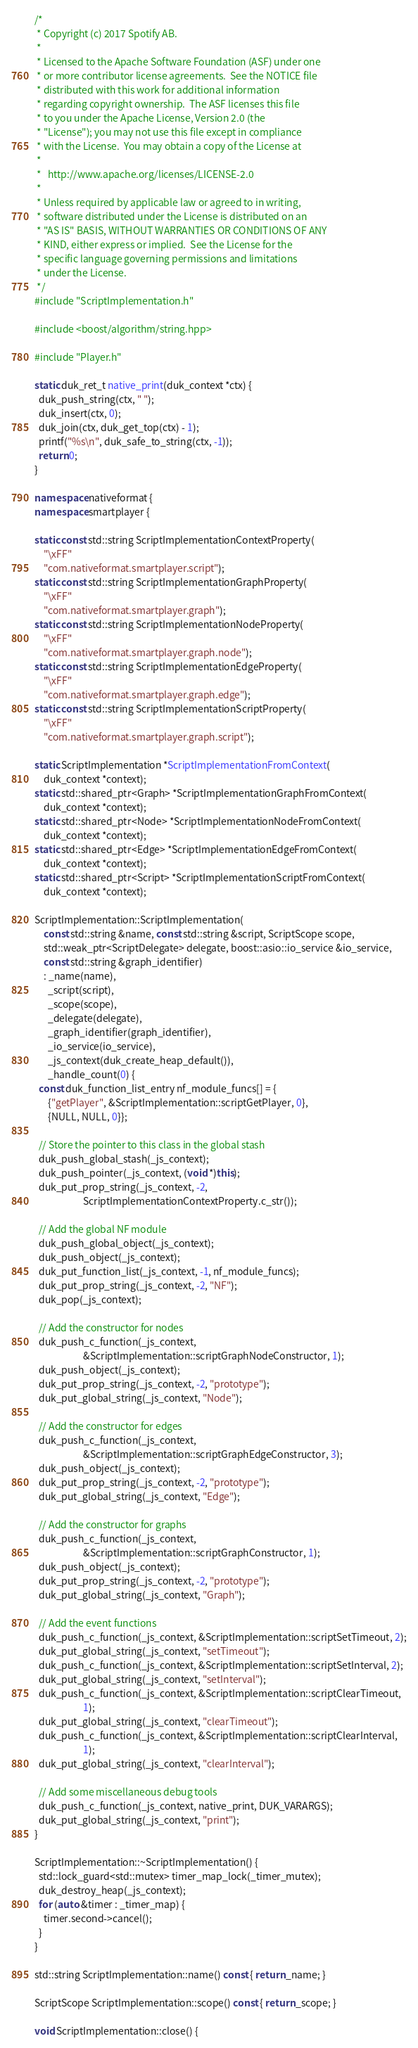Convert code to text. <code><loc_0><loc_0><loc_500><loc_500><_C++_>/*
 * Copyright (c) 2017 Spotify AB.
 *
 * Licensed to the Apache Software Foundation (ASF) under one
 * or more contributor license agreements.  See the NOTICE file
 * distributed with this work for additional information
 * regarding copyright ownership.  The ASF licenses this file
 * to you under the Apache License, Version 2.0 (the
 * "License"); you may not use this file except in compliance
 * with the License.  You may obtain a copy of the License at
 *
 *   http://www.apache.org/licenses/LICENSE-2.0
 *
 * Unless required by applicable law or agreed to in writing,
 * software distributed under the License is distributed on an
 * "AS IS" BASIS, WITHOUT WARRANTIES OR CONDITIONS OF ANY
 * KIND, either express or implied.  See the License for the
 * specific language governing permissions and limitations
 * under the License.
 */
#include "ScriptImplementation.h"

#include <boost/algorithm/string.hpp>

#include "Player.h"

static duk_ret_t native_print(duk_context *ctx) {
  duk_push_string(ctx, " ");
  duk_insert(ctx, 0);
  duk_join(ctx, duk_get_top(ctx) - 1);
  printf("%s\n", duk_safe_to_string(ctx, -1));
  return 0;
}

namespace nativeformat {
namespace smartplayer {

static const std::string ScriptImplementationContextProperty(
    "\xFF"
    "com.nativeformat.smartplayer.script");
static const std::string ScriptImplementationGraphProperty(
    "\xFF"
    "com.nativeformat.smartplayer.graph");
static const std::string ScriptImplementationNodeProperty(
    "\xFF"
    "com.nativeformat.smartplayer.graph.node");
static const std::string ScriptImplementationEdgeProperty(
    "\xFF"
    "com.nativeformat.smartplayer.graph.edge");
static const std::string ScriptImplementationScriptProperty(
    "\xFF"
    "com.nativeformat.smartplayer.graph.script");

static ScriptImplementation *ScriptImplementationFromContext(
    duk_context *context);
static std::shared_ptr<Graph> *ScriptImplementationGraphFromContext(
    duk_context *context);
static std::shared_ptr<Node> *ScriptImplementationNodeFromContext(
    duk_context *context);
static std::shared_ptr<Edge> *ScriptImplementationEdgeFromContext(
    duk_context *context);
static std::shared_ptr<Script> *ScriptImplementationScriptFromContext(
    duk_context *context);

ScriptImplementation::ScriptImplementation(
    const std::string &name, const std::string &script, ScriptScope scope,
    std::weak_ptr<ScriptDelegate> delegate, boost::asio::io_service &io_service,
    const std::string &graph_identifier)
    : _name(name),
      _script(script),
      _scope(scope),
      _delegate(delegate),
      _graph_identifier(graph_identifier),
      _io_service(io_service),
      _js_context(duk_create_heap_default()),
      _handle_count(0) {
  const duk_function_list_entry nf_module_funcs[] = {
      {"getPlayer", &ScriptImplementation::scriptGetPlayer, 0},
      {NULL, NULL, 0}};

  // Store the pointer to this class in the global stash
  duk_push_global_stash(_js_context);
  duk_push_pointer(_js_context, (void *)this);
  duk_put_prop_string(_js_context, -2,
                      ScriptImplementationContextProperty.c_str());

  // Add the global NF module
  duk_push_global_object(_js_context);
  duk_push_object(_js_context);
  duk_put_function_list(_js_context, -1, nf_module_funcs);
  duk_put_prop_string(_js_context, -2, "NF");
  duk_pop(_js_context);

  // Add the constructor for nodes
  duk_push_c_function(_js_context,
                      &ScriptImplementation::scriptGraphNodeConstructor, 1);
  duk_push_object(_js_context);
  duk_put_prop_string(_js_context, -2, "prototype");
  duk_put_global_string(_js_context, "Node");

  // Add the constructor for edges
  duk_push_c_function(_js_context,
                      &ScriptImplementation::scriptGraphEdgeConstructor, 3);
  duk_push_object(_js_context);
  duk_put_prop_string(_js_context, -2, "prototype");
  duk_put_global_string(_js_context, "Edge");

  // Add the constructor for graphs
  duk_push_c_function(_js_context,
                      &ScriptImplementation::scriptGraphConstructor, 1);
  duk_push_object(_js_context);
  duk_put_prop_string(_js_context, -2, "prototype");
  duk_put_global_string(_js_context, "Graph");

  // Add the event functions
  duk_push_c_function(_js_context, &ScriptImplementation::scriptSetTimeout, 2);
  duk_put_global_string(_js_context, "setTimeout");
  duk_push_c_function(_js_context, &ScriptImplementation::scriptSetInterval, 2);
  duk_put_global_string(_js_context, "setInterval");
  duk_push_c_function(_js_context, &ScriptImplementation::scriptClearTimeout,
                      1);
  duk_put_global_string(_js_context, "clearTimeout");
  duk_push_c_function(_js_context, &ScriptImplementation::scriptClearInterval,
                      1);
  duk_put_global_string(_js_context, "clearInterval");

  // Add some miscellaneous debug tools
  duk_push_c_function(_js_context, native_print, DUK_VARARGS);
  duk_put_global_string(_js_context, "print");
}

ScriptImplementation::~ScriptImplementation() {
  std::lock_guard<std::mutex> timer_map_lock(_timer_mutex);
  duk_destroy_heap(_js_context);
  for (auto &timer : _timer_map) {
    timer.second->cancel();
  }
}

std::string ScriptImplementation::name() const { return _name; }

ScriptScope ScriptImplementation::scope() const { return _scope; }

void ScriptImplementation::close() {</code> 